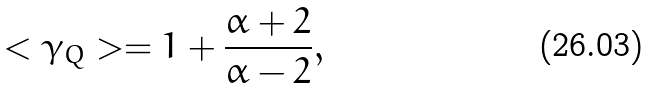Convert formula to latex. <formula><loc_0><loc_0><loc_500><loc_500>< \gamma _ { Q } > = 1 + \frac { \alpha + 2 } { \alpha - 2 } ,</formula> 